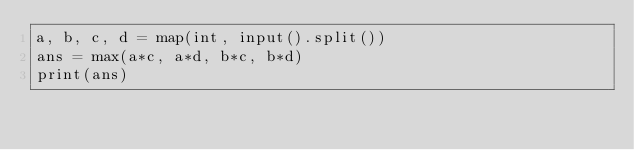<code> <loc_0><loc_0><loc_500><loc_500><_Python_>a, b, c, d = map(int, input().split())
ans = max(a*c, a*d, b*c, b*d)
print(ans)</code> 